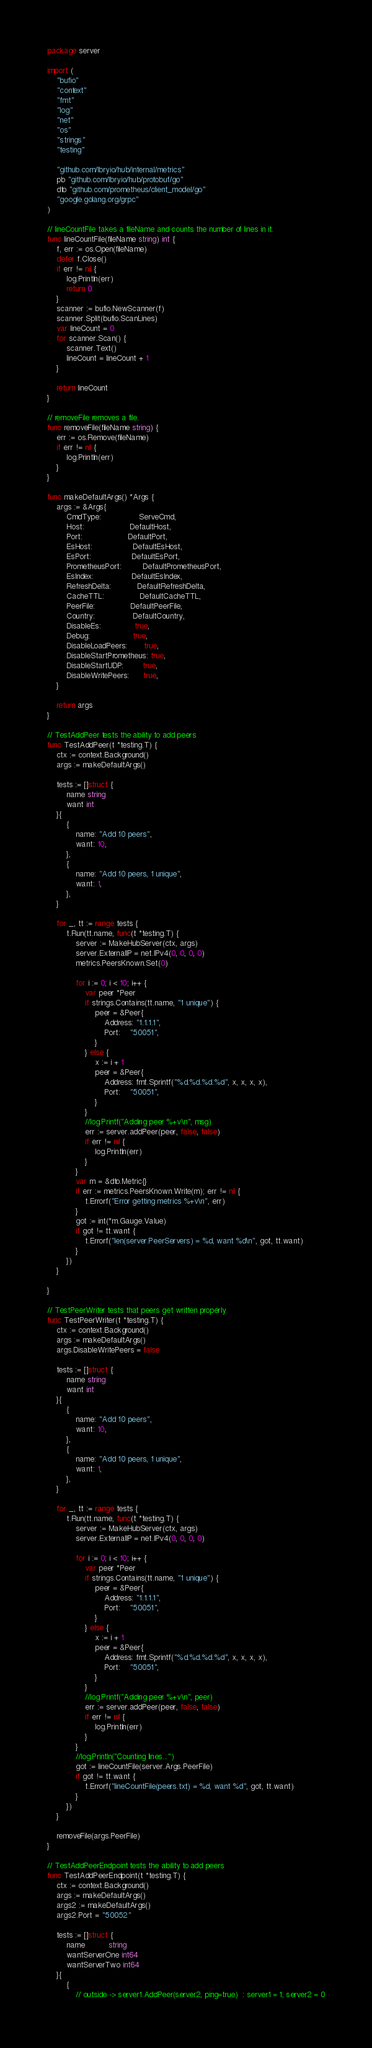<code> <loc_0><loc_0><loc_500><loc_500><_Go_>package server

import (
	"bufio"
	"context"
	"fmt"
	"log"
	"net"
	"os"
	"strings"
	"testing"

	"github.com/lbryio/hub/internal/metrics"
	pb "github.com/lbryio/hub/protobuf/go"
	dto "github.com/prometheus/client_model/go"
	"google.golang.org/grpc"
)

// lineCountFile takes a fileName and counts the number of lines in it.
func lineCountFile(fileName string) int {
	f, err := os.Open(fileName)
	defer f.Close()
	if err != nil {
		log.Println(err)
		return 0
	}
	scanner := bufio.NewScanner(f)
	scanner.Split(bufio.ScanLines)
	var lineCount = 0
	for scanner.Scan() {
		scanner.Text()
		lineCount = lineCount + 1
	}

	return lineCount
}

// removeFile removes a file.
func removeFile(fileName string) {
	err := os.Remove(fileName)
	if err != nil {
		log.Println(err)
	}
}

func makeDefaultArgs() *Args {
	args := &Args{
		CmdType:                ServeCmd,
		Host:                   DefaultHost,
		Port:                   DefaultPort,
		EsHost:                 DefaultEsHost,
		EsPort:                 DefaultEsPort,
		PrometheusPort:         DefaultPrometheusPort,
		EsIndex:                DefaultEsIndex,
		RefreshDelta:           DefaultRefreshDelta,
		CacheTTL:               DefaultCacheTTL,
		PeerFile:               DefaultPeerFile,
		Country:                DefaultCountry,
		DisableEs:              true,
		Debug:                  true,
		DisableLoadPeers:       true,
		DisableStartPrometheus: true,
		DisableStartUDP:        true,
		DisableWritePeers:      true,
	}

	return args
}

// TestAddPeer tests the ability to add peers
func TestAddPeer(t *testing.T) {
	ctx := context.Background()
	args := makeDefaultArgs()

	tests := []struct {
		name string
		want int
	}{
		{
			name: "Add 10 peers",
			want: 10,
		},
		{
			name: "Add 10 peers, 1 unique",
			want: 1,
		},
	}

	for _, tt := range tests {
		t.Run(tt.name, func(t *testing.T) {
			server := MakeHubServer(ctx, args)
			server.ExternalIP = net.IPv4(0, 0, 0, 0)
			metrics.PeersKnown.Set(0)

			for i := 0; i < 10; i++ {
				var peer *Peer
				if strings.Contains(tt.name, "1 unique") {
					peer = &Peer{
						Address: "1.1.1.1",
						Port:    "50051",
					}
				} else {
					x := i + 1
					peer = &Peer{
						Address: fmt.Sprintf("%d.%d.%d.%d", x, x, x, x),
						Port:    "50051",
					}
				}
				//log.Printf("Adding peer %+v\n", msg)
				err := server.addPeer(peer, false, false)
				if err != nil {
					log.Println(err)
				}
			}
			var m = &dto.Metric{}
			if err := metrics.PeersKnown.Write(m); err != nil {
				t.Errorf("Error getting metrics %+v\n", err)
			}
			got := int(*m.Gauge.Value)
			if got != tt.want {
				t.Errorf("len(server.PeerServers) = %d, want %d\n", got, tt.want)
			}
		})
	}

}

// TestPeerWriter tests that peers get written properly
func TestPeerWriter(t *testing.T) {
	ctx := context.Background()
	args := makeDefaultArgs()
	args.DisableWritePeers = false

	tests := []struct {
		name string
		want int
	}{
		{
			name: "Add 10 peers",
			want: 10,
		},
		{
			name: "Add 10 peers, 1 unique",
			want: 1,
		},
	}

	for _, tt := range tests {
		t.Run(tt.name, func(t *testing.T) {
			server := MakeHubServer(ctx, args)
			server.ExternalIP = net.IPv4(0, 0, 0, 0)

			for i := 0; i < 10; i++ {
				var peer *Peer
				if strings.Contains(tt.name, "1 unique") {
					peer = &Peer{
						Address: "1.1.1.1",
						Port:    "50051",
					}
				} else {
					x := i + 1
					peer = &Peer{
						Address: fmt.Sprintf("%d.%d.%d.%d", x, x, x, x),
						Port:    "50051",
					}
				}
				//log.Printf("Adding peer %+v\n", peer)
				err := server.addPeer(peer, false, false)
				if err != nil {
					log.Println(err)
				}
			}
			//log.Println("Counting lines...")
			got := lineCountFile(server.Args.PeerFile)
			if got != tt.want {
				t.Errorf("lineCountFile(peers.txt) = %d, want %d", got, tt.want)
			}
		})
	}

	removeFile(args.PeerFile)
}

// TestAddPeerEndpoint tests the ability to add peers
func TestAddPeerEndpoint(t *testing.T) {
	ctx := context.Background()
	args := makeDefaultArgs()
	args2 := makeDefaultArgs()
	args2.Port = "50052"

	tests := []struct {
		name          string
		wantServerOne int64
		wantServerTwo int64
	}{
		{
			// outside -> server1.AddPeer(server2, ping=true)  : server1 = 1, server2 = 0</code> 